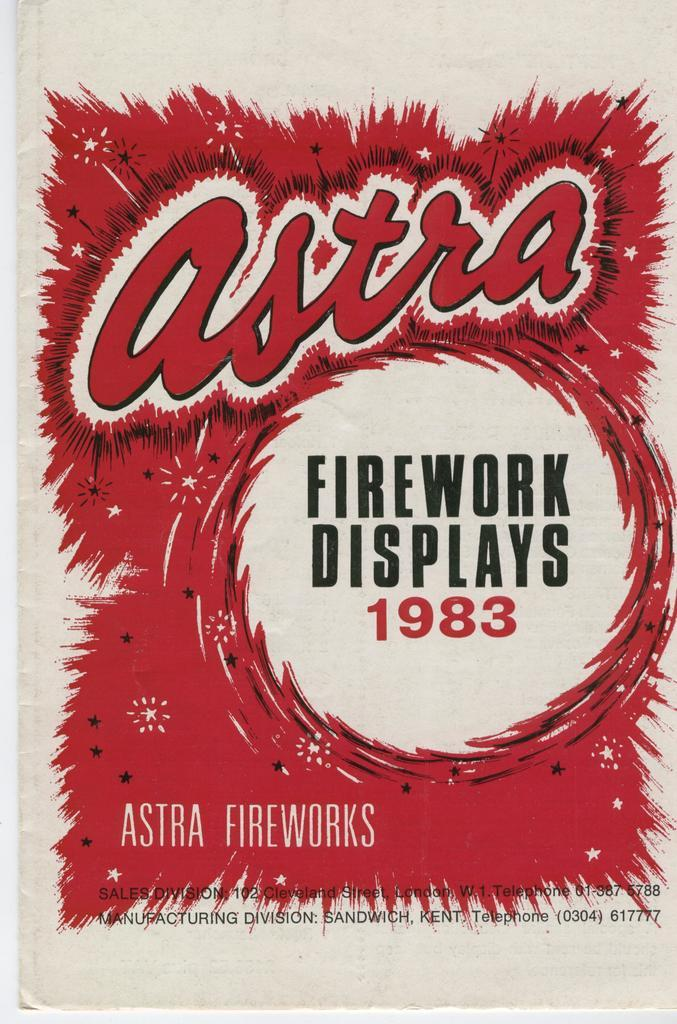Provide a one-sentence caption for the provided image. a sign display that says firework displays 1983. 